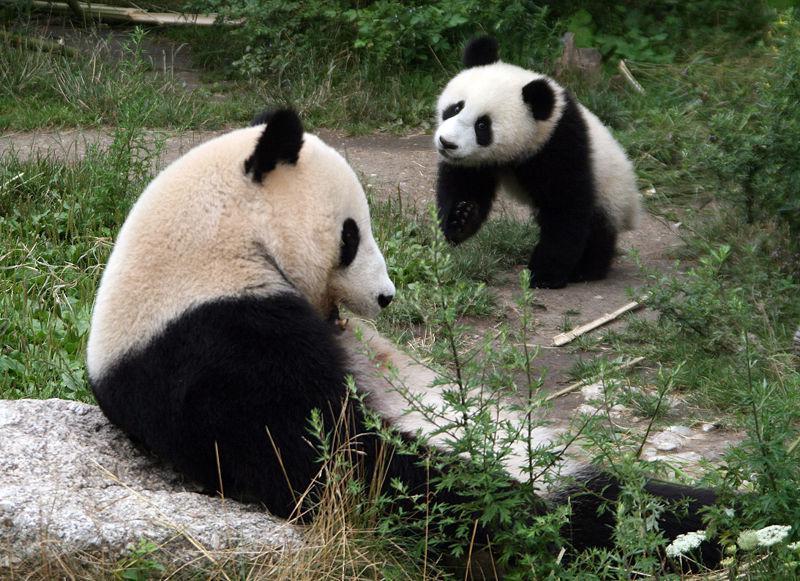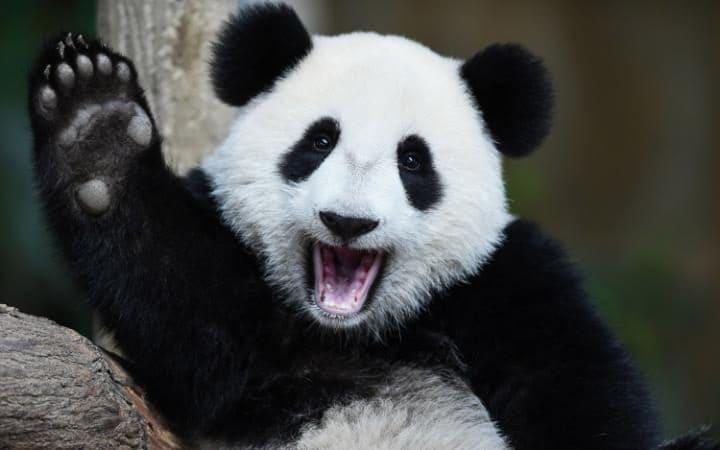The first image is the image on the left, the second image is the image on the right. Examine the images to the left and right. Is the description "There are two pandas in one of the pictures." accurate? Answer yes or no. Yes. 